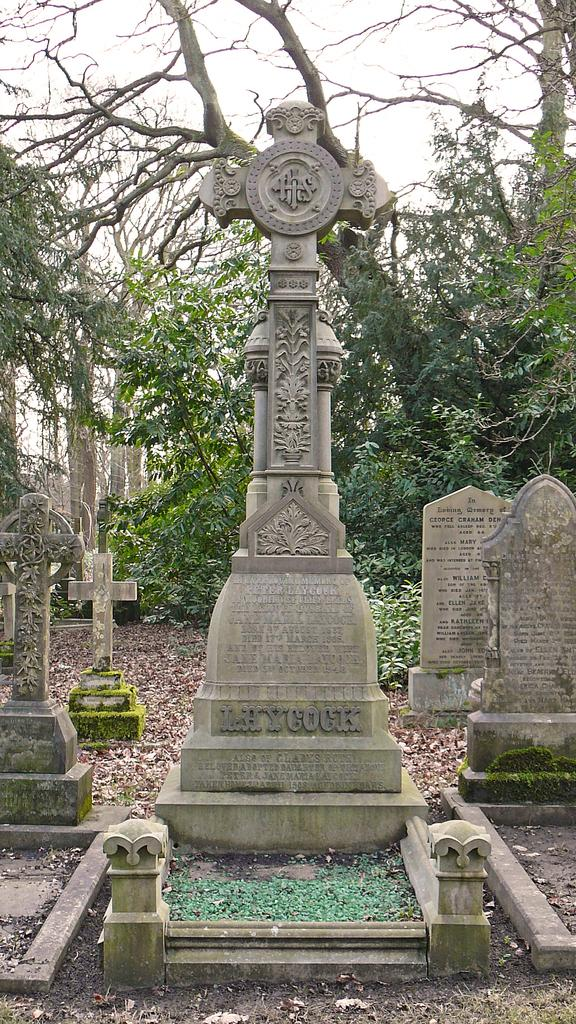What type of location is depicted in the image? There is a cemetery in the image. What can be seen in the background of the image? There are many trees and the sky visible in the background of the image. What type of nation is represented by the cemetery in the image? The image does not represent a specific nation; it simply shows a cemetery with trees and the sky in the background. 